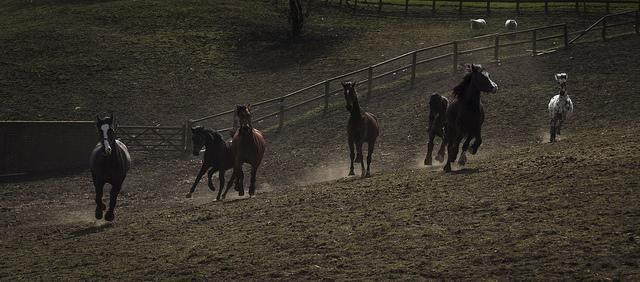What is used to keep the horses in one area? Please explain your reasoning. fences. The horses are fenced. 